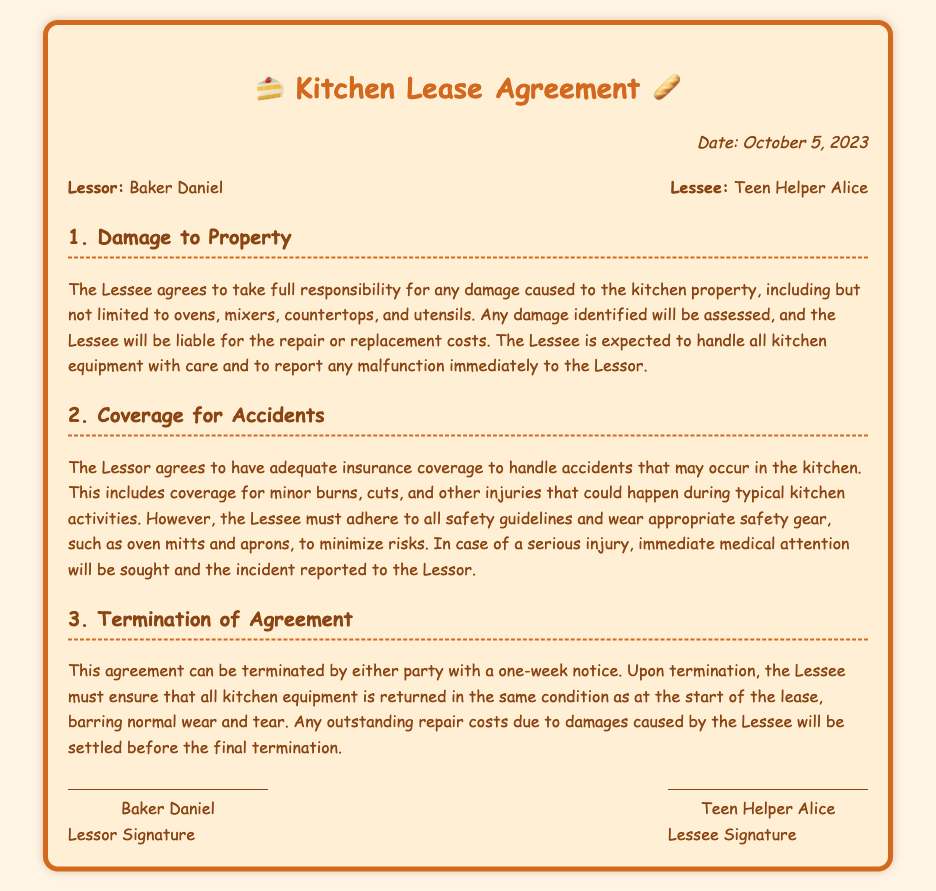What date was the lease agreement signed? The date of the lease agreement is explicitly stated in the document.
Answer: October 5, 2023 Who is the Lessor in the agreement? The Lessor is named at the beginning of the document.
Answer: Baker Daniel What kind of injuries are covered under the Lessor's insurance? The document lists specific injuries that fall under the coverage provided by the Lessor.
Answer: Minor burns, cuts What must the Lessee do if they cause damage? The responsibility of the Lessee regarding damage is detailed in the document.
Answer: Pay for repair or replacement costs What is required of the Lessee in terms of equipment handling? The document specifies expectations for the Lessee in relation to kitchen equipment.
Answer: Handle with care How much notice is needed to terminate the Lease Agreement? The agreement includes a specific notice period for termination.
Answer: One week What should the Lessee wear to minimize kitchen risks? The document mentions specific safety gear that the Lessee should use.
Answer: Oven mitts and aprons What must happen in case of a serious injury? The document outlines the procedure to follow if a serious incident occurs.
Answer: Seek immediate medical attention 